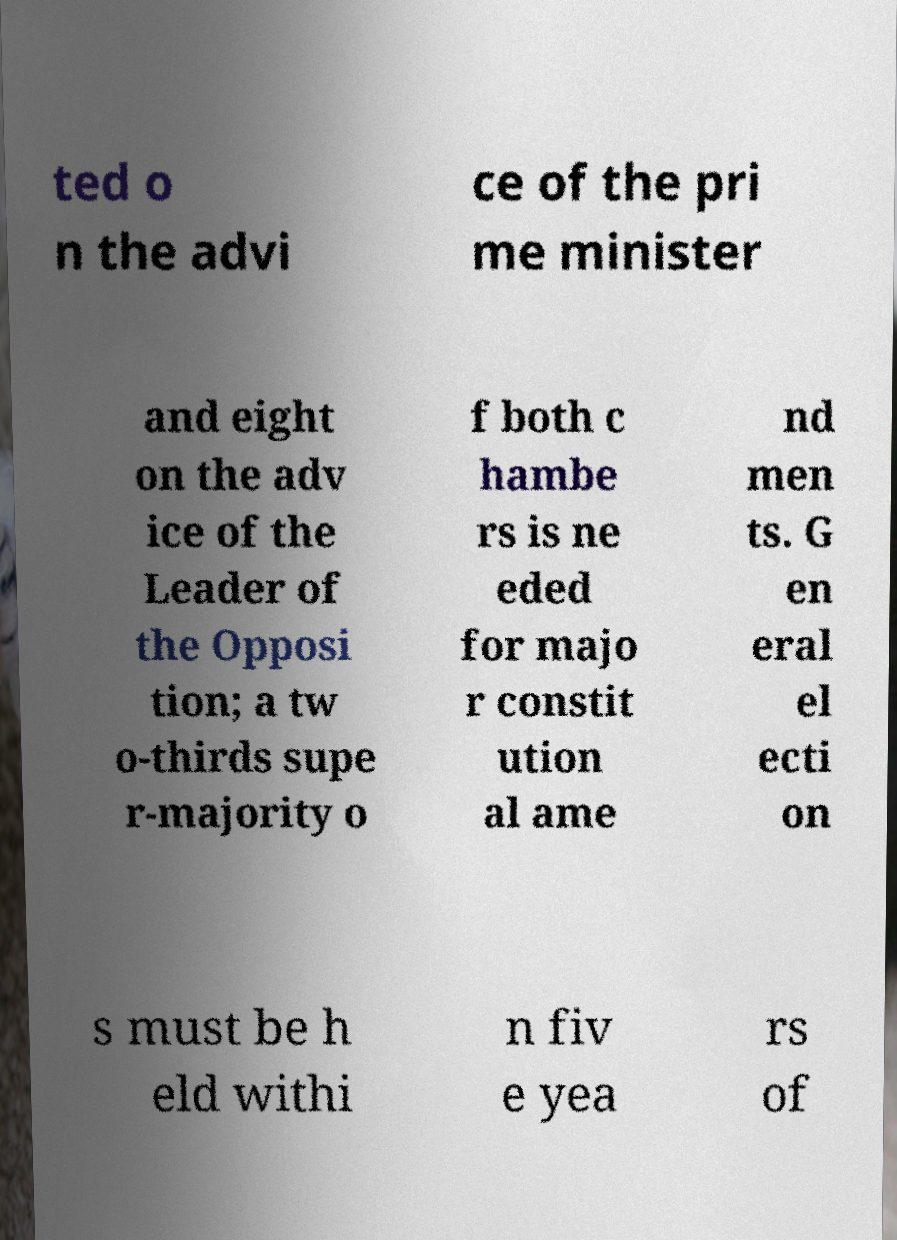There's text embedded in this image that I need extracted. Can you transcribe it verbatim? ted o n the advi ce of the pri me minister and eight on the adv ice of the Leader of the Opposi tion; a tw o-thirds supe r-majority o f both c hambe rs is ne eded for majo r constit ution al ame nd men ts. G en eral el ecti on s must be h eld withi n fiv e yea rs of 